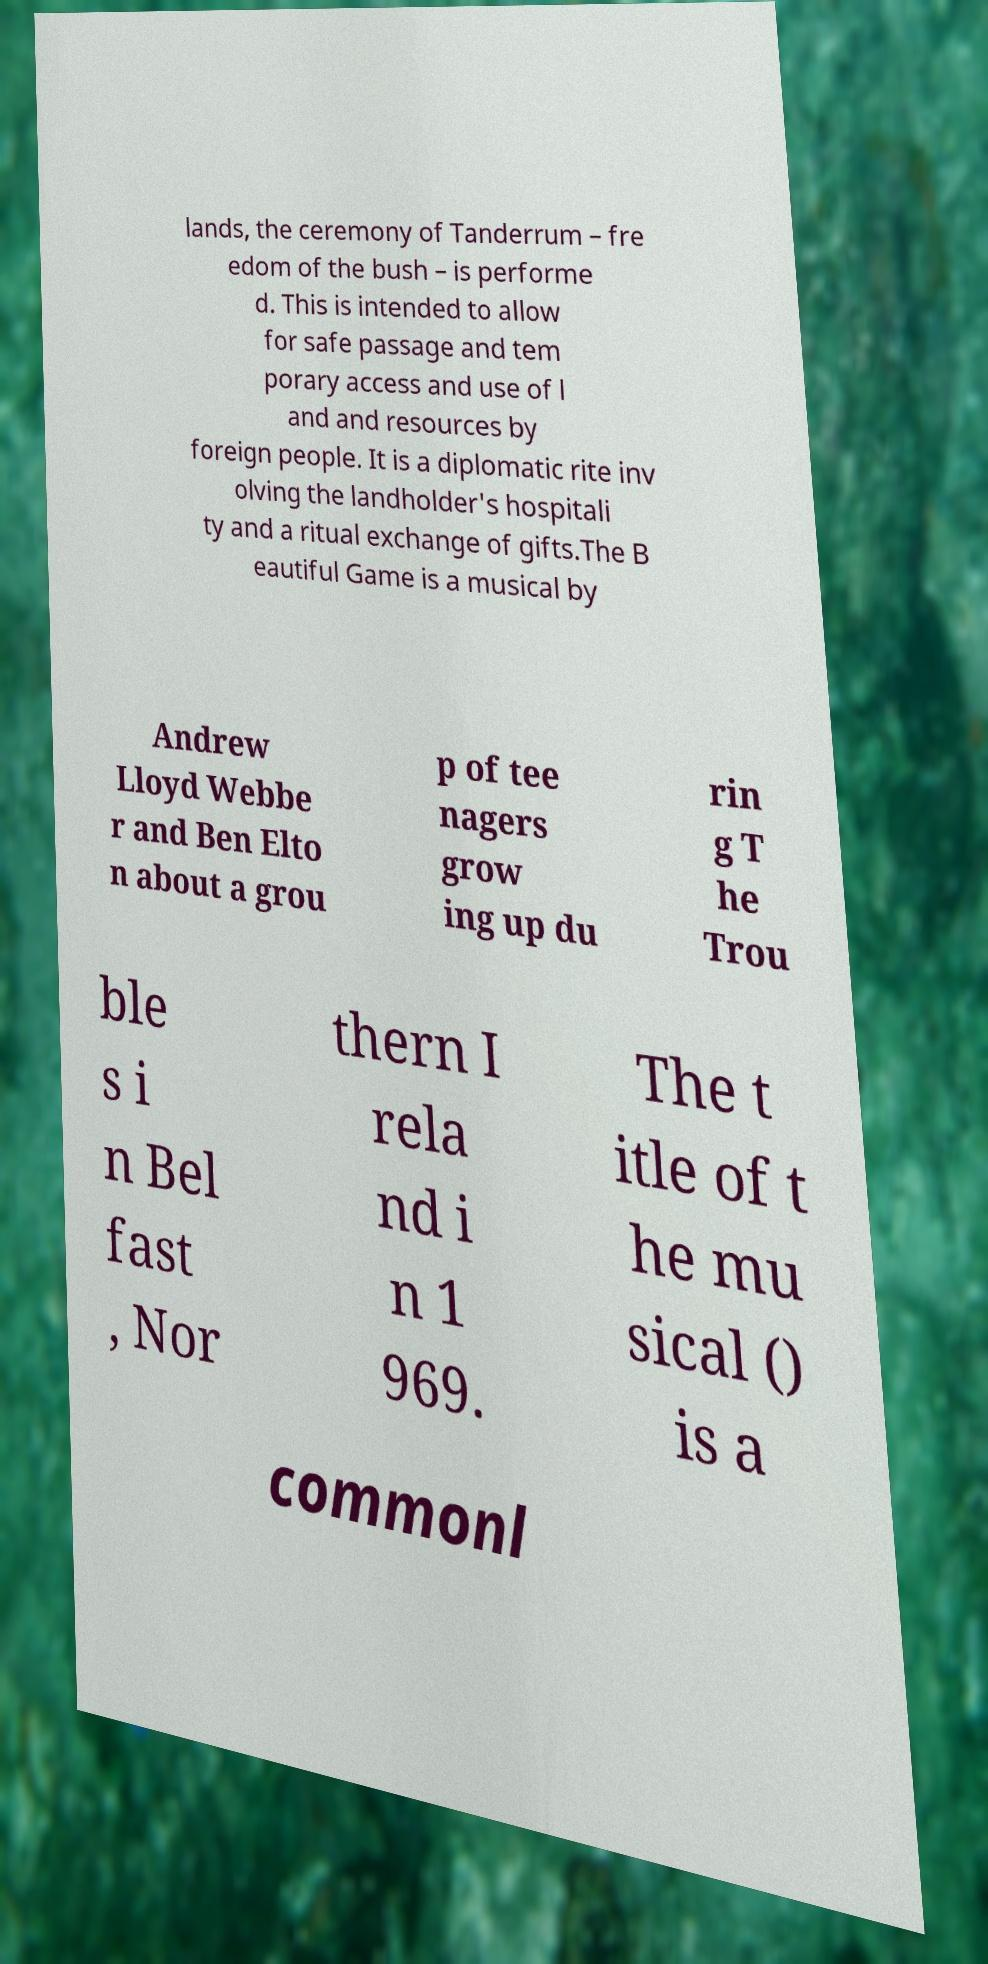For documentation purposes, I need the text within this image transcribed. Could you provide that? lands, the ceremony of Tanderrum – fre edom of the bush – is performe d. This is intended to allow for safe passage and tem porary access and use of l and and resources by foreign people. It is a diplomatic rite inv olving the landholder's hospitali ty and a ritual exchange of gifts.The B eautiful Game is a musical by Andrew Lloyd Webbe r and Ben Elto n about a grou p of tee nagers grow ing up du rin g T he Trou ble s i n Bel fast , Nor thern I rela nd i n 1 969. The t itle of t he mu sical () is a commonl 